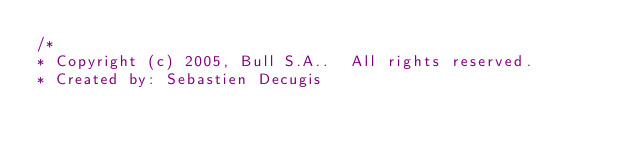<code> <loc_0><loc_0><loc_500><loc_500><_C_>/*
* Copyright (c) 2005, Bull S.A..  All rights reserved.
* Created by: Sebastien Decugis</code> 